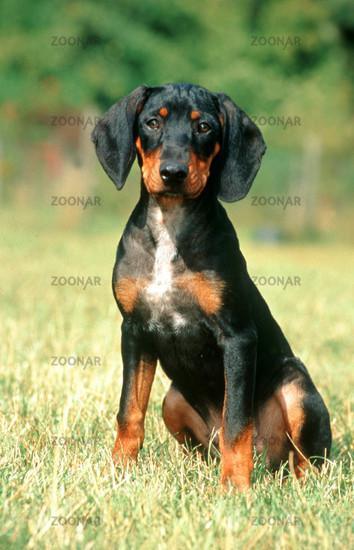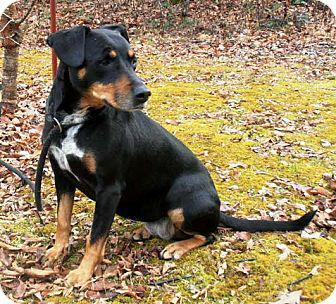The first image is the image on the left, the second image is the image on the right. Evaluate the accuracy of this statement regarding the images: "The left image includes side-by-side, identically-posed, forward-facing dobermans with erect pointy ears, and the right image contains two dobermans with floppy ears.". Is it true? Answer yes or no. No. The first image is the image on the left, the second image is the image on the right. For the images shown, is this caption "A darker colored dog is lying next to a lighter colored one of the same breed in at least one image." true? Answer yes or no. No. 